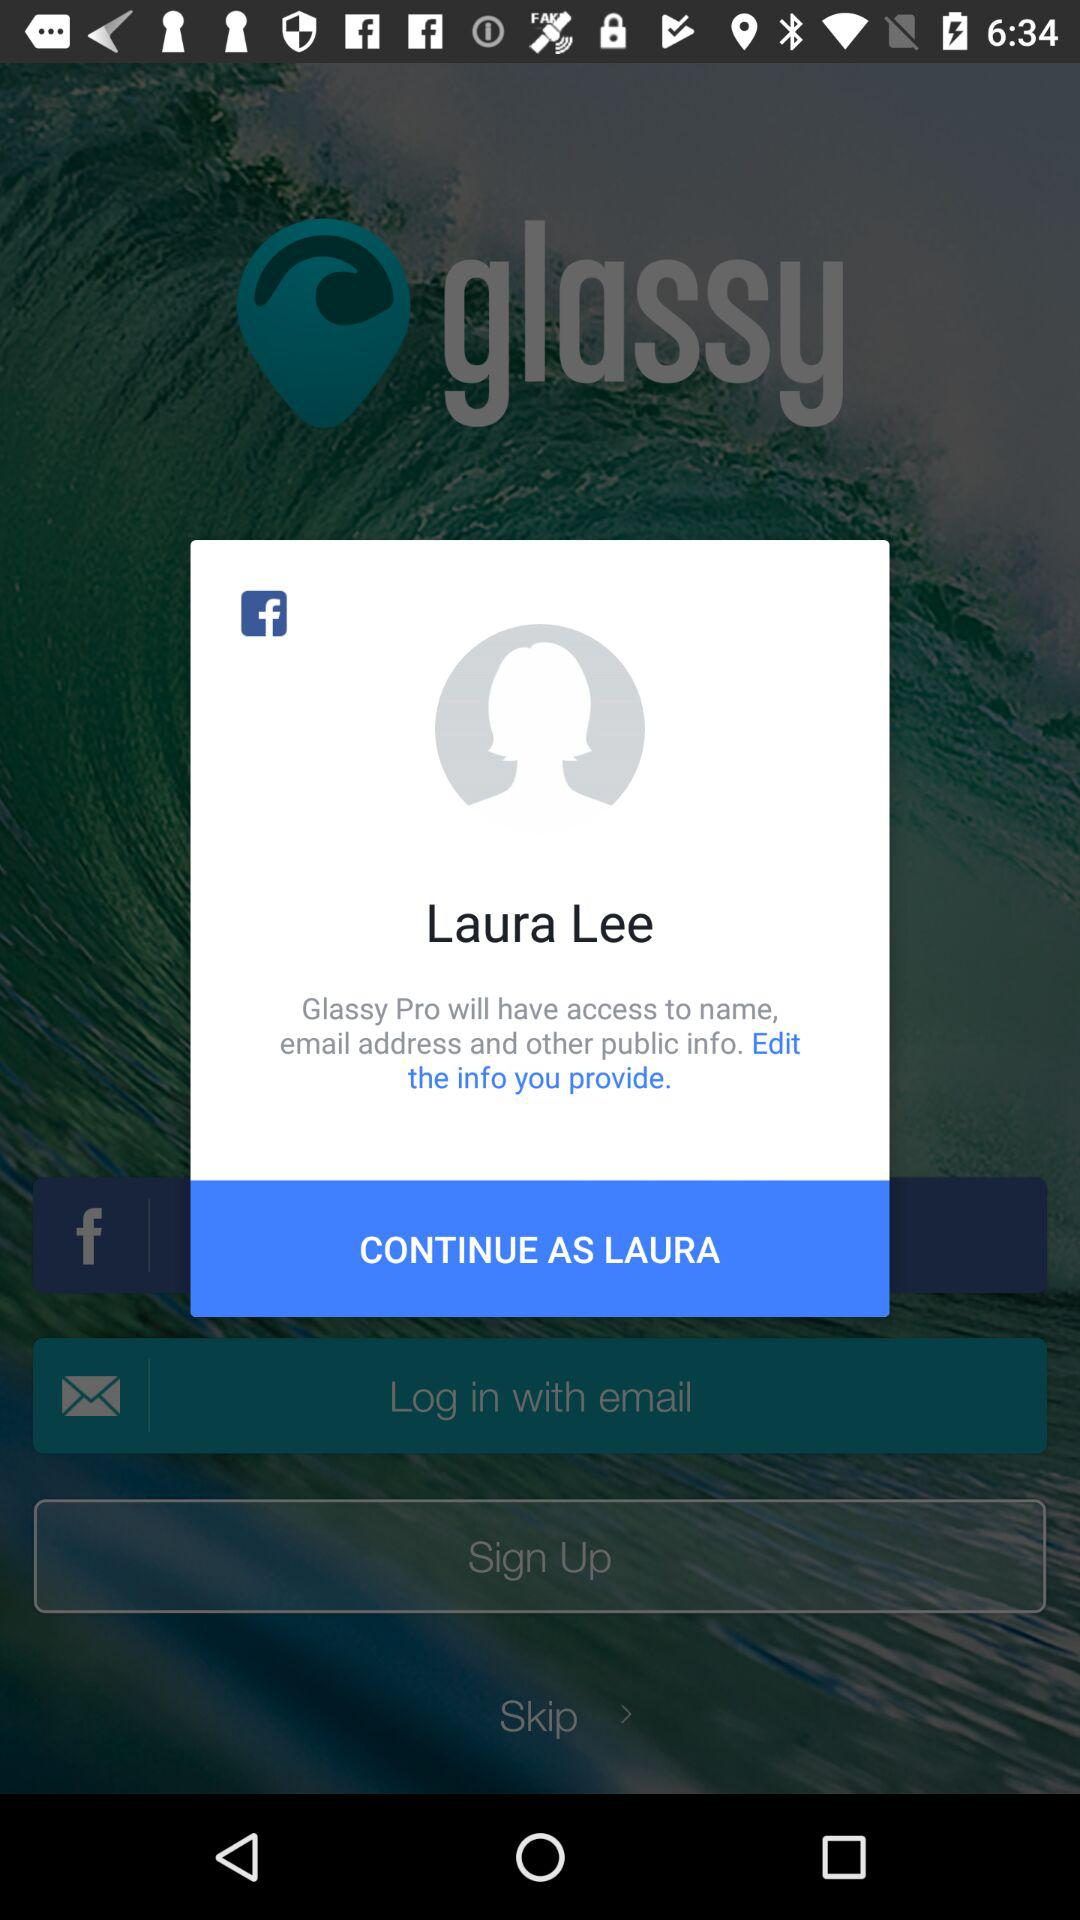What is the user name? The user name is Laura Lee. 